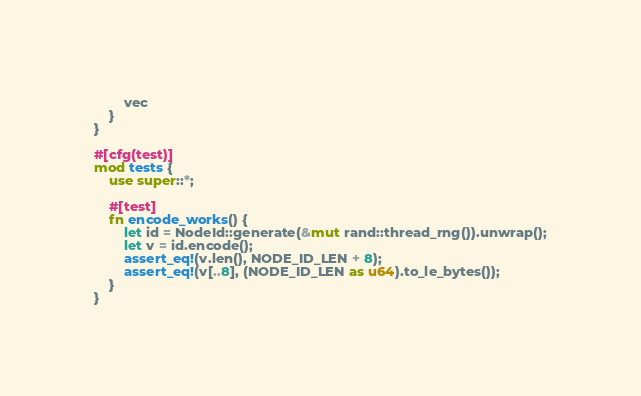<code> <loc_0><loc_0><loc_500><loc_500><_Rust_>        vec
    }
}

#[cfg(test)]
mod tests {
    use super::*;

    #[test]
    fn encode_works() {
        let id = NodeId::generate(&mut rand::thread_rng()).unwrap();
        let v = id.encode();
        assert_eq!(v.len(), NODE_ID_LEN + 8);
        assert_eq!(v[..8], (NODE_ID_LEN as u64).to_le_bytes());
    }
}
</code> 